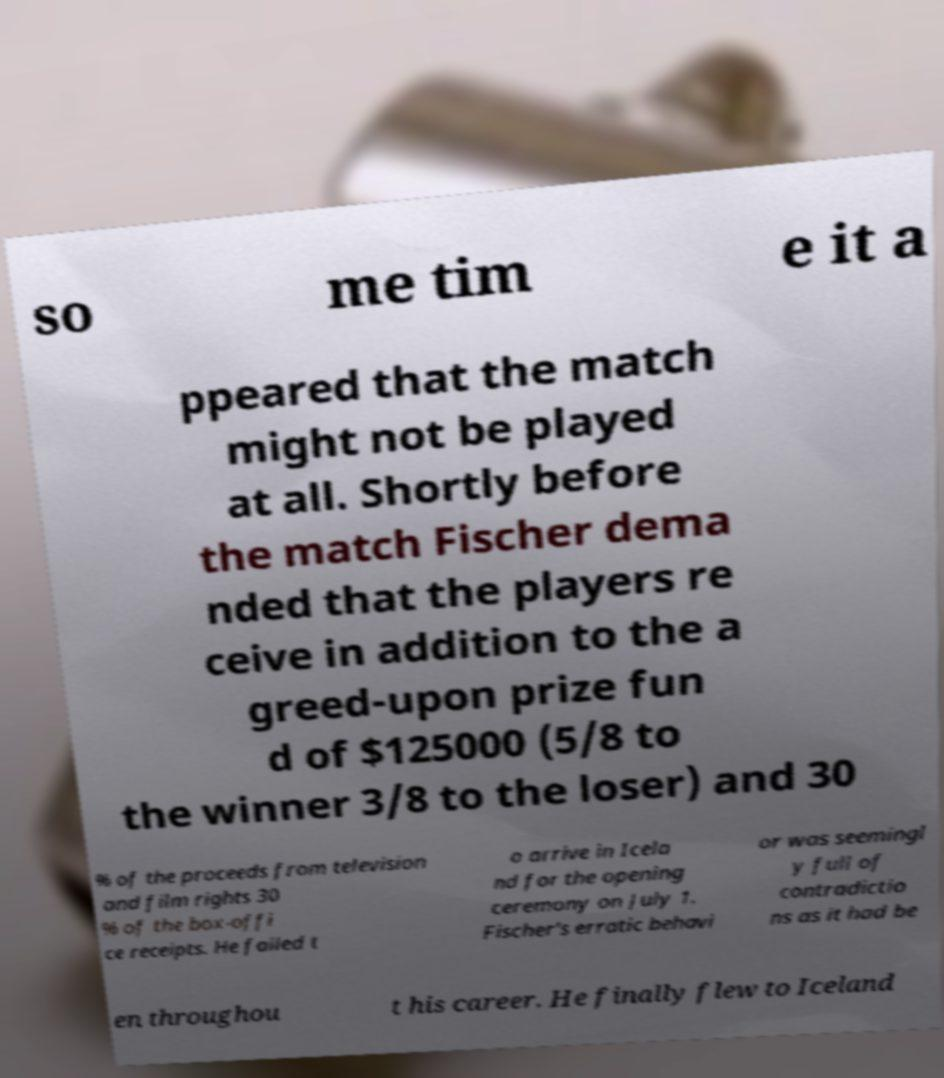Could you extract and type out the text from this image? so me tim e it a ppeared that the match might not be played at all. Shortly before the match Fischer dema nded that the players re ceive in addition to the a greed-upon prize fun d of $125000 (5/8 to the winner 3/8 to the loser) and 30 % of the proceeds from television and film rights 30 % of the box-offi ce receipts. He failed t o arrive in Icela nd for the opening ceremony on July 1. Fischer's erratic behavi or was seemingl y full of contradictio ns as it had be en throughou t his career. He finally flew to Iceland 